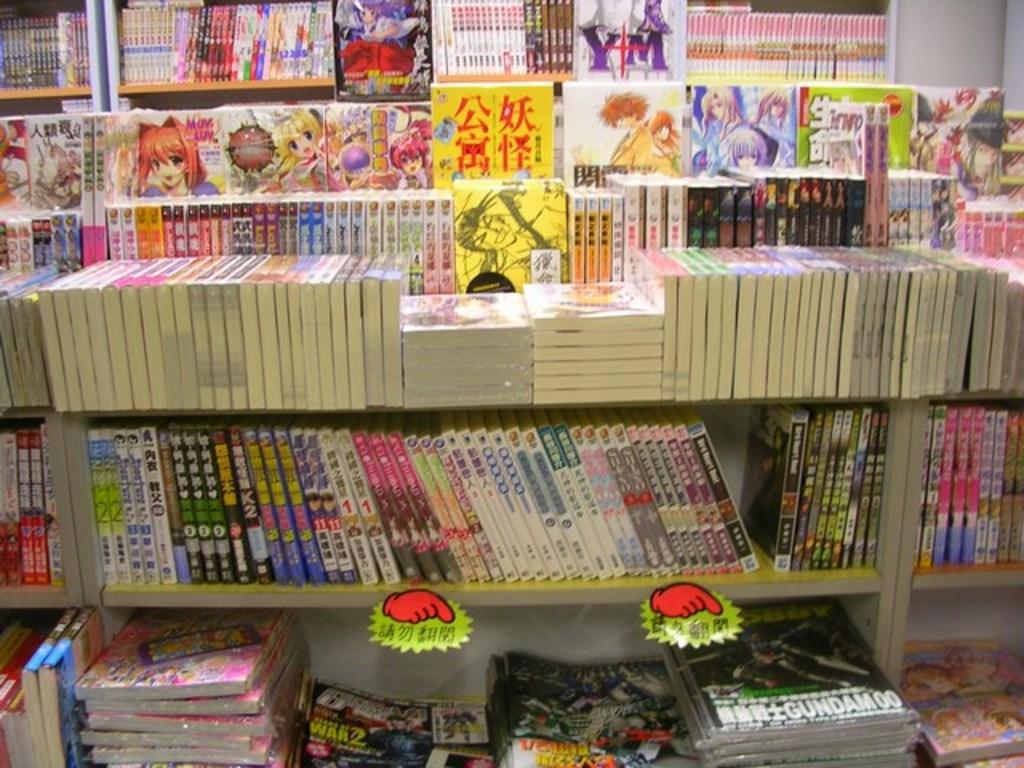What objects are present in the image? There are different types of books in the image. How are the books organized in the image? The books are arranged in racks. What type of tail can be seen on the books in the image? There are no tails present on the books in the image. What event is taking place in the image? The image does not depict any specific event; it simply shows books arranged in racks. 